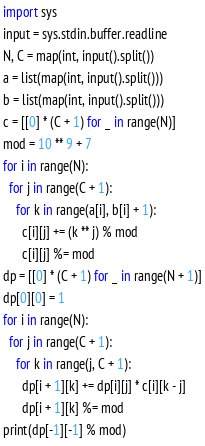<code> <loc_0><loc_0><loc_500><loc_500><_Python_>import sys
input = sys.stdin.buffer.readline
N, C = map(int, input().split())
a = list(map(int, input().split()))
b = list(map(int, input().split()))
c = [[0] * (C + 1) for _ in range(N)]
mod = 10 ** 9 + 7
for i in range(N):
  for j in range(C + 1):
    for k in range(a[i], b[i] + 1):
      c[i][j] += (k ** j) % mod
      c[i][j] %= mod
dp = [[0] * (C + 1) for _ in range(N + 1)]
dp[0][0] = 1
for i in range(N):
  for j in range(C + 1):
    for k in range(j, C + 1):
      dp[i + 1][k] += dp[i][j] * c[i][k - j]
      dp[i + 1][k] %= mod
print(dp[-1][-1] % mod)</code> 